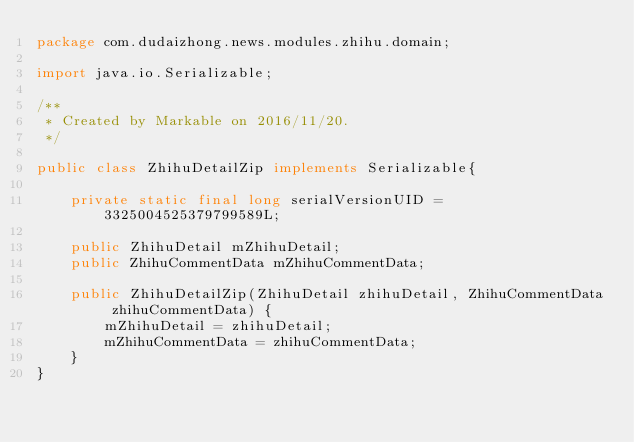Convert code to text. <code><loc_0><loc_0><loc_500><loc_500><_Java_>package com.dudaizhong.news.modules.zhihu.domain;

import java.io.Serializable;

/**
 * Created by Markable on 2016/11/20.
 */

public class ZhihuDetailZip implements Serializable{

    private static final long serialVersionUID = 3325004525379799589L;

    public ZhihuDetail mZhihuDetail;
    public ZhihuCommentData mZhihuCommentData;

    public ZhihuDetailZip(ZhihuDetail zhihuDetail, ZhihuCommentData zhihuCommentData) {
        mZhihuDetail = zhihuDetail;
        mZhihuCommentData = zhihuCommentData;
    }
}
</code> 